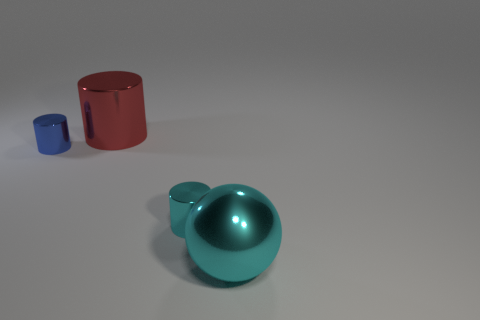Can you tell me what colors are predominant in the image? The predominant colors in the image are teal and red. The large sphere is teal, and one of the cylinders is red, which stand out against the neutral background. 